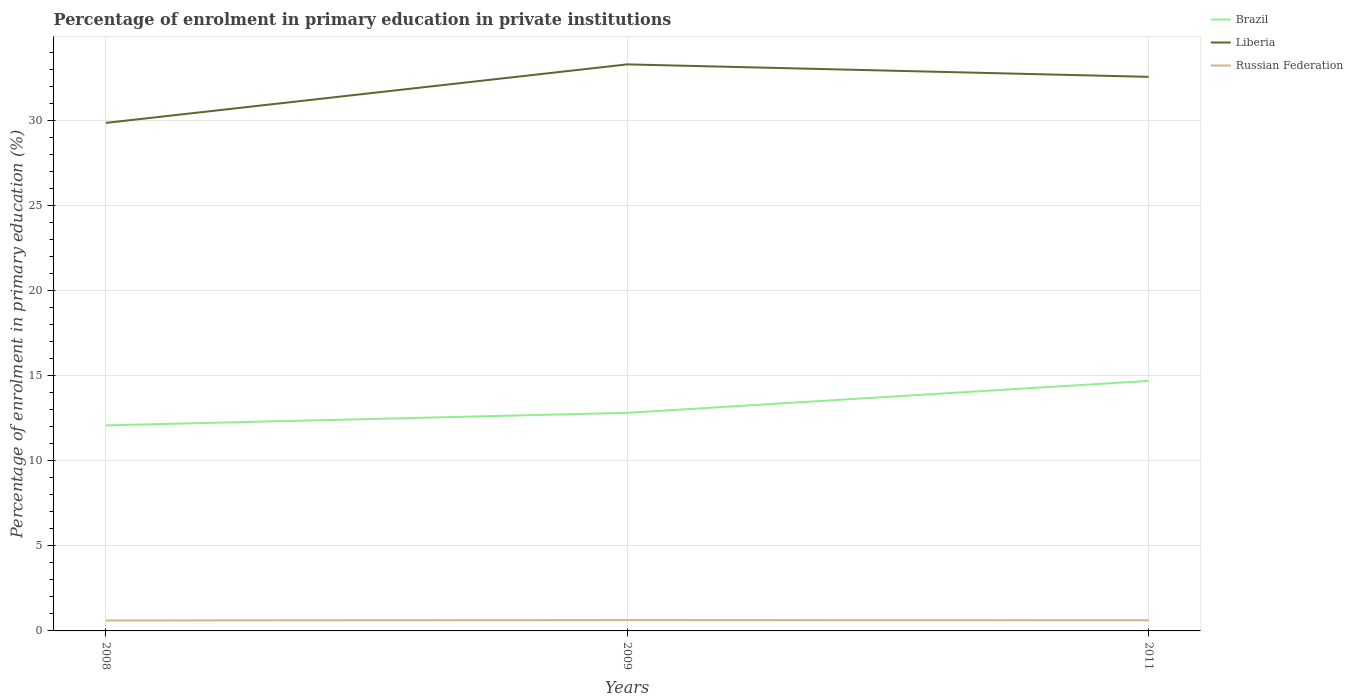How many different coloured lines are there?
Offer a terse response. 3. Is the number of lines equal to the number of legend labels?
Ensure brevity in your answer.  Yes. Across all years, what is the maximum percentage of enrolment in primary education in Russian Federation?
Offer a terse response. 0.61. In which year was the percentage of enrolment in primary education in Liberia maximum?
Offer a very short reply. 2008. What is the total percentage of enrolment in primary education in Liberia in the graph?
Your response must be concise. -2.71. What is the difference between the highest and the second highest percentage of enrolment in primary education in Russian Federation?
Make the answer very short. 0.02. What is the difference between the highest and the lowest percentage of enrolment in primary education in Brazil?
Your answer should be very brief. 1. What is the difference between two consecutive major ticks on the Y-axis?
Your response must be concise. 5. Are the values on the major ticks of Y-axis written in scientific E-notation?
Your answer should be very brief. No. Does the graph contain any zero values?
Give a very brief answer. No. Does the graph contain grids?
Give a very brief answer. Yes. How are the legend labels stacked?
Ensure brevity in your answer.  Vertical. What is the title of the graph?
Provide a short and direct response. Percentage of enrolment in primary education in private institutions. Does "Low income" appear as one of the legend labels in the graph?
Your answer should be very brief. No. What is the label or title of the Y-axis?
Offer a very short reply. Percentage of enrolment in primary education (%). What is the Percentage of enrolment in primary education (%) in Brazil in 2008?
Offer a very short reply. 12.08. What is the Percentage of enrolment in primary education (%) in Liberia in 2008?
Make the answer very short. 29.85. What is the Percentage of enrolment in primary education (%) of Russian Federation in 2008?
Keep it short and to the point. 0.61. What is the Percentage of enrolment in primary education (%) in Brazil in 2009?
Provide a succinct answer. 12.81. What is the Percentage of enrolment in primary education (%) of Liberia in 2009?
Provide a short and direct response. 33.28. What is the Percentage of enrolment in primary education (%) of Russian Federation in 2009?
Ensure brevity in your answer.  0.64. What is the Percentage of enrolment in primary education (%) of Brazil in 2011?
Provide a short and direct response. 14.69. What is the Percentage of enrolment in primary education (%) of Liberia in 2011?
Offer a very short reply. 32.55. What is the Percentage of enrolment in primary education (%) of Russian Federation in 2011?
Your answer should be very brief. 0.63. Across all years, what is the maximum Percentage of enrolment in primary education (%) in Brazil?
Your answer should be compact. 14.69. Across all years, what is the maximum Percentage of enrolment in primary education (%) of Liberia?
Your answer should be compact. 33.28. Across all years, what is the maximum Percentage of enrolment in primary education (%) of Russian Federation?
Offer a very short reply. 0.64. Across all years, what is the minimum Percentage of enrolment in primary education (%) in Brazil?
Give a very brief answer. 12.08. Across all years, what is the minimum Percentage of enrolment in primary education (%) of Liberia?
Make the answer very short. 29.85. Across all years, what is the minimum Percentage of enrolment in primary education (%) of Russian Federation?
Your answer should be compact. 0.61. What is the total Percentage of enrolment in primary education (%) in Brazil in the graph?
Your response must be concise. 39.58. What is the total Percentage of enrolment in primary education (%) in Liberia in the graph?
Your answer should be very brief. 95.68. What is the total Percentage of enrolment in primary education (%) in Russian Federation in the graph?
Your answer should be compact. 1.88. What is the difference between the Percentage of enrolment in primary education (%) in Brazil in 2008 and that in 2009?
Offer a very short reply. -0.74. What is the difference between the Percentage of enrolment in primary education (%) of Liberia in 2008 and that in 2009?
Your answer should be compact. -3.44. What is the difference between the Percentage of enrolment in primary education (%) in Russian Federation in 2008 and that in 2009?
Ensure brevity in your answer.  -0.02. What is the difference between the Percentage of enrolment in primary education (%) in Brazil in 2008 and that in 2011?
Your answer should be very brief. -2.61. What is the difference between the Percentage of enrolment in primary education (%) of Liberia in 2008 and that in 2011?
Offer a very short reply. -2.71. What is the difference between the Percentage of enrolment in primary education (%) of Russian Federation in 2008 and that in 2011?
Offer a very short reply. -0.01. What is the difference between the Percentage of enrolment in primary education (%) of Brazil in 2009 and that in 2011?
Your answer should be compact. -1.88. What is the difference between the Percentage of enrolment in primary education (%) in Liberia in 2009 and that in 2011?
Offer a terse response. 0.73. What is the difference between the Percentage of enrolment in primary education (%) in Russian Federation in 2009 and that in 2011?
Keep it short and to the point. 0.01. What is the difference between the Percentage of enrolment in primary education (%) of Brazil in 2008 and the Percentage of enrolment in primary education (%) of Liberia in 2009?
Your answer should be very brief. -21.21. What is the difference between the Percentage of enrolment in primary education (%) in Brazil in 2008 and the Percentage of enrolment in primary education (%) in Russian Federation in 2009?
Your response must be concise. 11.44. What is the difference between the Percentage of enrolment in primary education (%) in Liberia in 2008 and the Percentage of enrolment in primary education (%) in Russian Federation in 2009?
Provide a short and direct response. 29.21. What is the difference between the Percentage of enrolment in primary education (%) in Brazil in 2008 and the Percentage of enrolment in primary education (%) in Liberia in 2011?
Provide a short and direct response. -20.47. What is the difference between the Percentage of enrolment in primary education (%) of Brazil in 2008 and the Percentage of enrolment in primary education (%) of Russian Federation in 2011?
Give a very brief answer. 11.45. What is the difference between the Percentage of enrolment in primary education (%) of Liberia in 2008 and the Percentage of enrolment in primary education (%) of Russian Federation in 2011?
Keep it short and to the point. 29.22. What is the difference between the Percentage of enrolment in primary education (%) of Brazil in 2009 and the Percentage of enrolment in primary education (%) of Liberia in 2011?
Your answer should be very brief. -19.74. What is the difference between the Percentage of enrolment in primary education (%) in Brazil in 2009 and the Percentage of enrolment in primary education (%) in Russian Federation in 2011?
Make the answer very short. 12.19. What is the difference between the Percentage of enrolment in primary education (%) in Liberia in 2009 and the Percentage of enrolment in primary education (%) in Russian Federation in 2011?
Ensure brevity in your answer.  32.66. What is the average Percentage of enrolment in primary education (%) of Brazil per year?
Keep it short and to the point. 13.19. What is the average Percentage of enrolment in primary education (%) in Liberia per year?
Offer a terse response. 31.89. What is the average Percentage of enrolment in primary education (%) of Russian Federation per year?
Your answer should be compact. 0.63. In the year 2008, what is the difference between the Percentage of enrolment in primary education (%) of Brazil and Percentage of enrolment in primary education (%) of Liberia?
Give a very brief answer. -17.77. In the year 2008, what is the difference between the Percentage of enrolment in primary education (%) of Brazil and Percentage of enrolment in primary education (%) of Russian Federation?
Make the answer very short. 11.46. In the year 2008, what is the difference between the Percentage of enrolment in primary education (%) in Liberia and Percentage of enrolment in primary education (%) in Russian Federation?
Ensure brevity in your answer.  29.23. In the year 2009, what is the difference between the Percentage of enrolment in primary education (%) in Brazil and Percentage of enrolment in primary education (%) in Liberia?
Your answer should be very brief. -20.47. In the year 2009, what is the difference between the Percentage of enrolment in primary education (%) in Brazil and Percentage of enrolment in primary education (%) in Russian Federation?
Ensure brevity in your answer.  12.18. In the year 2009, what is the difference between the Percentage of enrolment in primary education (%) of Liberia and Percentage of enrolment in primary education (%) of Russian Federation?
Provide a succinct answer. 32.65. In the year 2011, what is the difference between the Percentage of enrolment in primary education (%) in Brazil and Percentage of enrolment in primary education (%) in Liberia?
Keep it short and to the point. -17.86. In the year 2011, what is the difference between the Percentage of enrolment in primary education (%) of Brazil and Percentage of enrolment in primary education (%) of Russian Federation?
Your answer should be very brief. 14.06. In the year 2011, what is the difference between the Percentage of enrolment in primary education (%) of Liberia and Percentage of enrolment in primary education (%) of Russian Federation?
Give a very brief answer. 31.92. What is the ratio of the Percentage of enrolment in primary education (%) in Brazil in 2008 to that in 2009?
Make the answer very short. 0.94. What is the ratio of the Percentage of enrolment in primary education (%) in Liberia in 2008 to that in 2009?
Provide a succinct answer. 0.9. What is the ratio of the Percentage of enrolment in primary education (%) in Russian Federation in 2008 to that in 2009?
Offer a terse response. 0.96. What is the ratio of the Percentage of enrolment in primary education (%) in Brazil in 2008 to that in 2011?
Offer a very short reply. 0.82. What is the ratio of the Percentage of enrolment in primary education (%) in Liberia in 2008 to that in 2011?
Your response must be concise. 0.92. What is the ratio of the Percentage of enrolment in primary education (%) in Russian Federation in 2008 to that in 2011?
Your answer should be compact. 0.98. What is the ratio of the Percentage of enrolment in primary education (%) in Brazil in 2009 to that in 2011?
Your answer should be very brief. 0.87. What is the ratio of the Percentage of enrolment in primary education (%) in Liberia in 2009 to that in 2011?
Make the answer very short. 1.02. What is the ratio of the Percentage of enrolment in primary education (%) in Russian Federation in 2009 to that in 2011?
Offer a terse response. 1.02. What is the difference between the highest and the second highest Percentage of enrolment in primary education (%) of Brazil?
Your response must be concise. 1.88. What is the difference between the highest and the second highest Percentage of enrolment in primary education (%) in Liberia?
Offer a terse response. 0.73. What is the difference between the highest and the second highest Percentage of enrolment in primary education (%) of Russian Federation?
Provide a short and direct response. 0.01. What is the difference between the highest and the lowest Percentage of enrolment in primary education (%) in Brazil?
Offer a very short reply. 2.61. What is the difference between the highest and the lowest Percentage of enrolment in primary education (%) in Liberia?
Give a very brief answer. 3.44. What is the difference between the highest and the lowest Percentage of enrolment in primary education (%) in Russian Federation?
Offer a terse response. 0.02. 